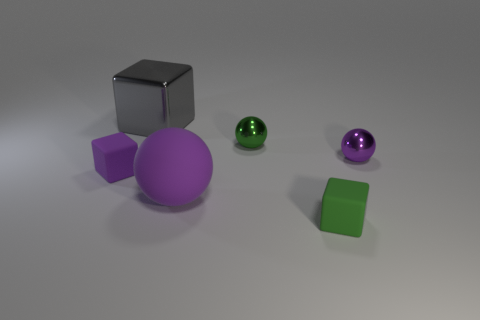If these objects were used in a physics lesson, what concept might they be used to explain? These objects could be great visual aids in a physics lesson on geometric shapes, volume, and surface area. Additionally, the different colors and materials (metallic and matte) could be used to discuss how light interacts with different surfaces, as well as concepts of density if they are assumed to be made of the same or different materials. 